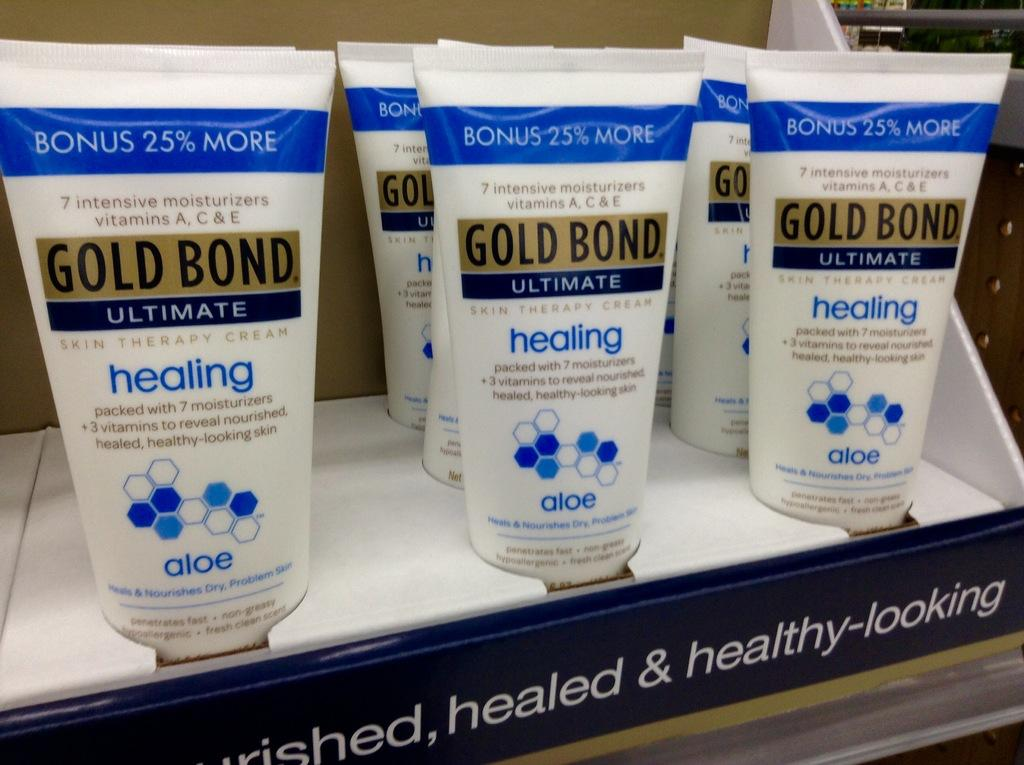<image>
Create a compact narrative representing the image presented. A display case is full of Gold Bond cream. 